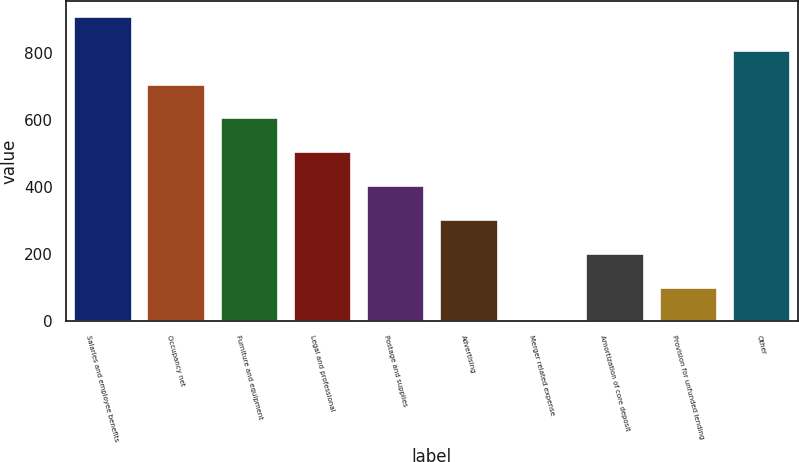<chart> <loc_0><loc_0><loc_500><loc_500><bar_chart><fcel>Salaries and employee benefits<fcel>Occupancy net<fcel>Furniture and equipment<fcel>Legal and professional<fcel>Postage and supplies<fcel>Advertising<fcel>Merger related expense<fcel>Amortization of core deposit<fcel>Provision for unfunded lending<fcel>Other<nl><fcel>911.85<fcel>709.95<fcel>609<fcel>508.05<fcel>407.1<fcel>306.15<fcel>3.3<fcel>205.2<fcel>104.25<fcel>810.9<nl></chart> 